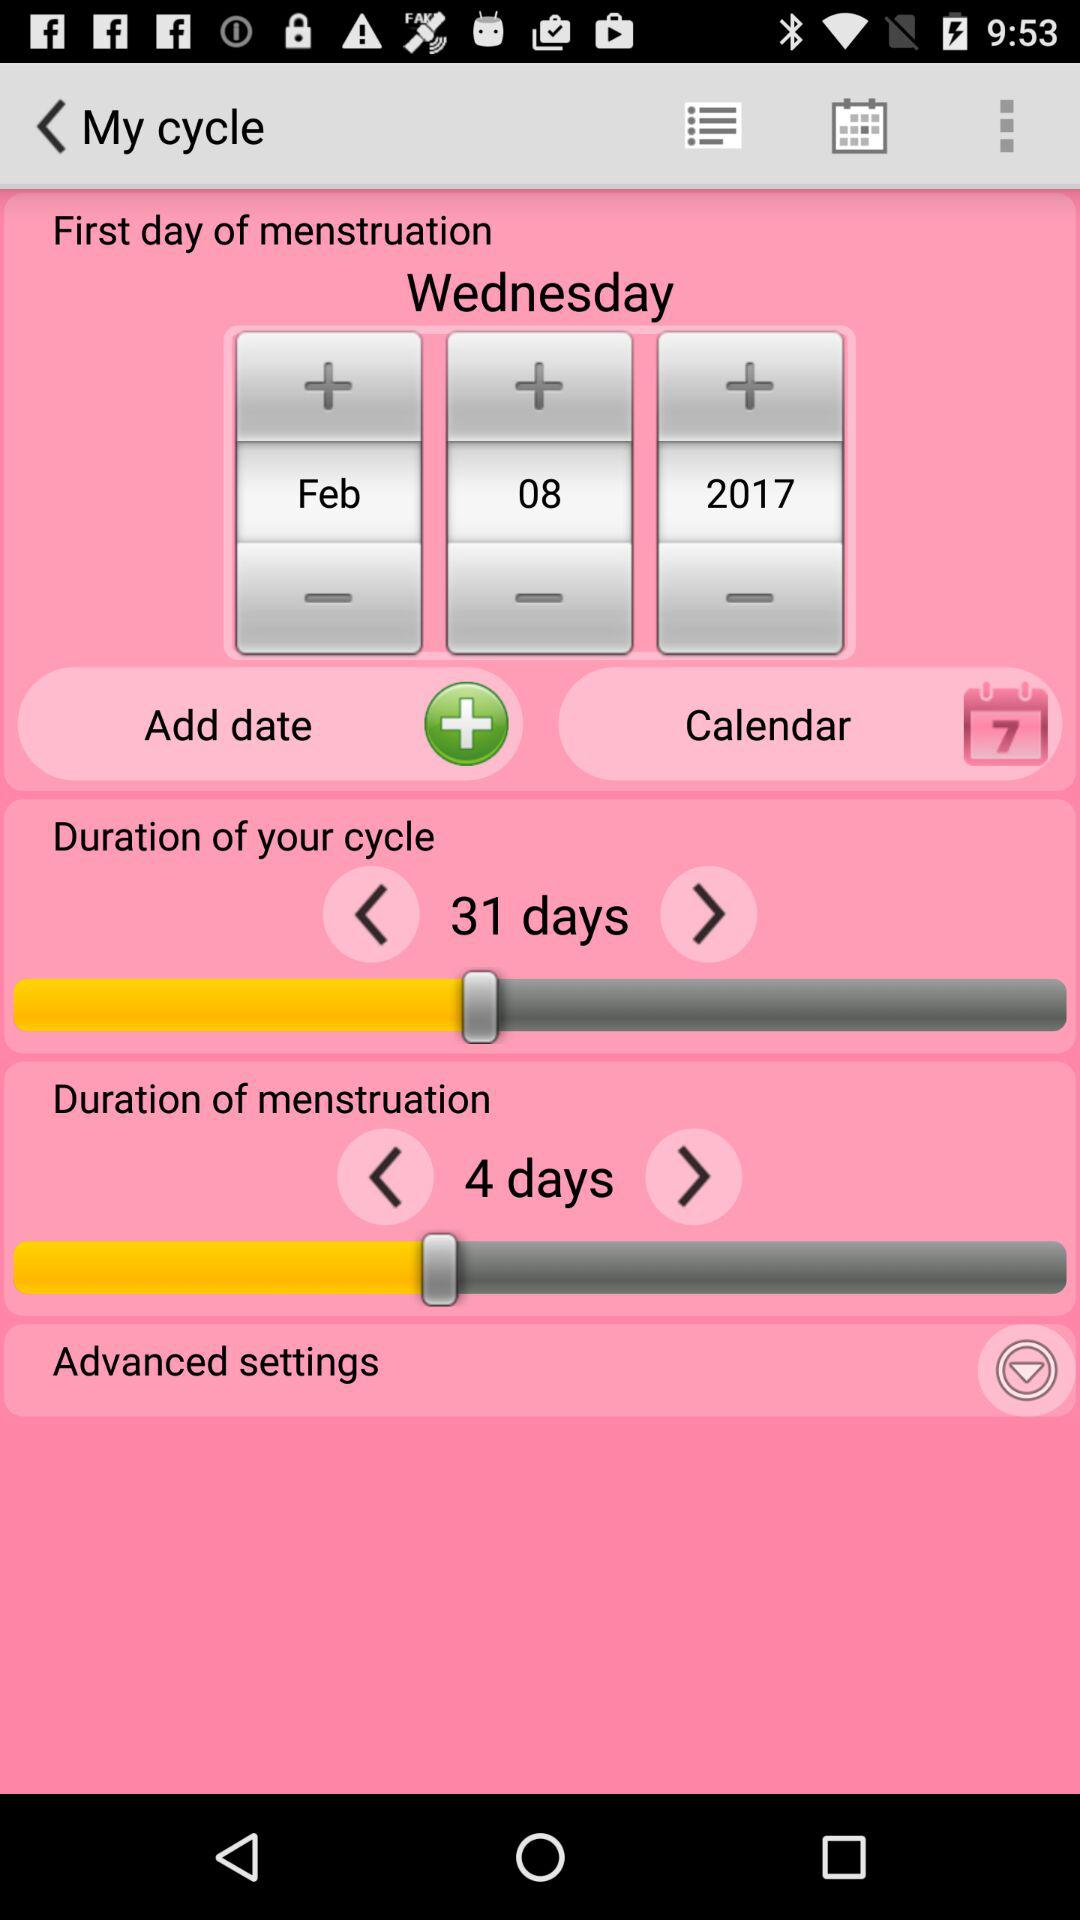How long is the menstrual duration? The menstrual duration is 4 days long. 